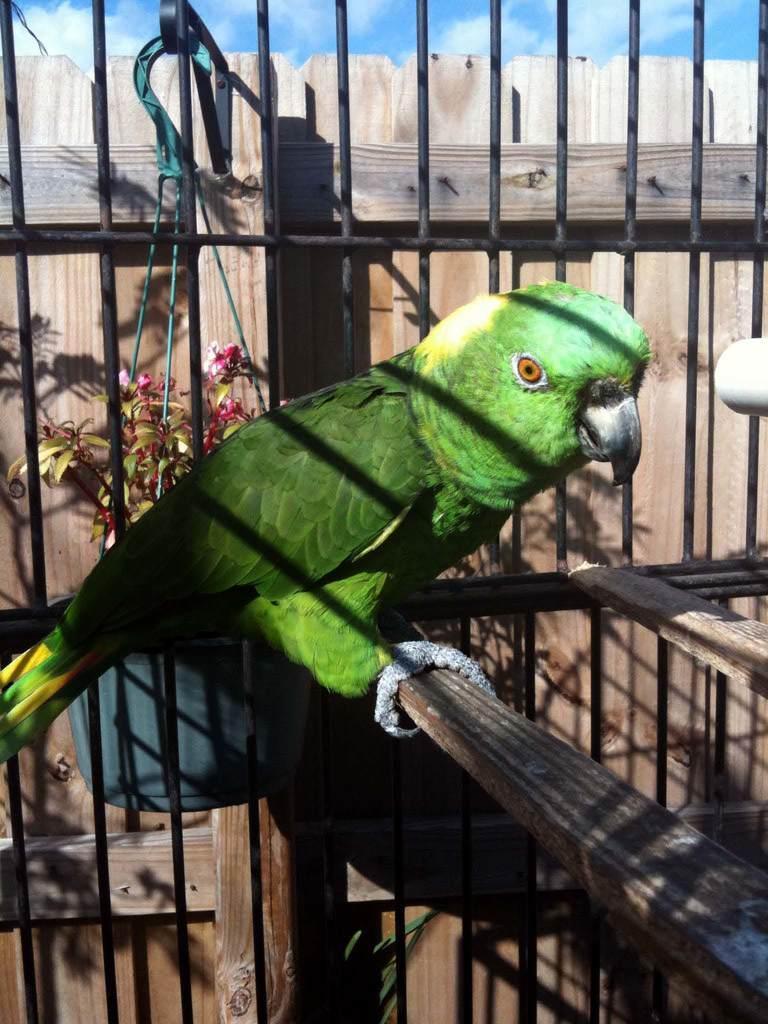How would you summarize this image in a sentence or two? In this image, we can see a green color parrot in the cage, at the top there is a blue color sky. 